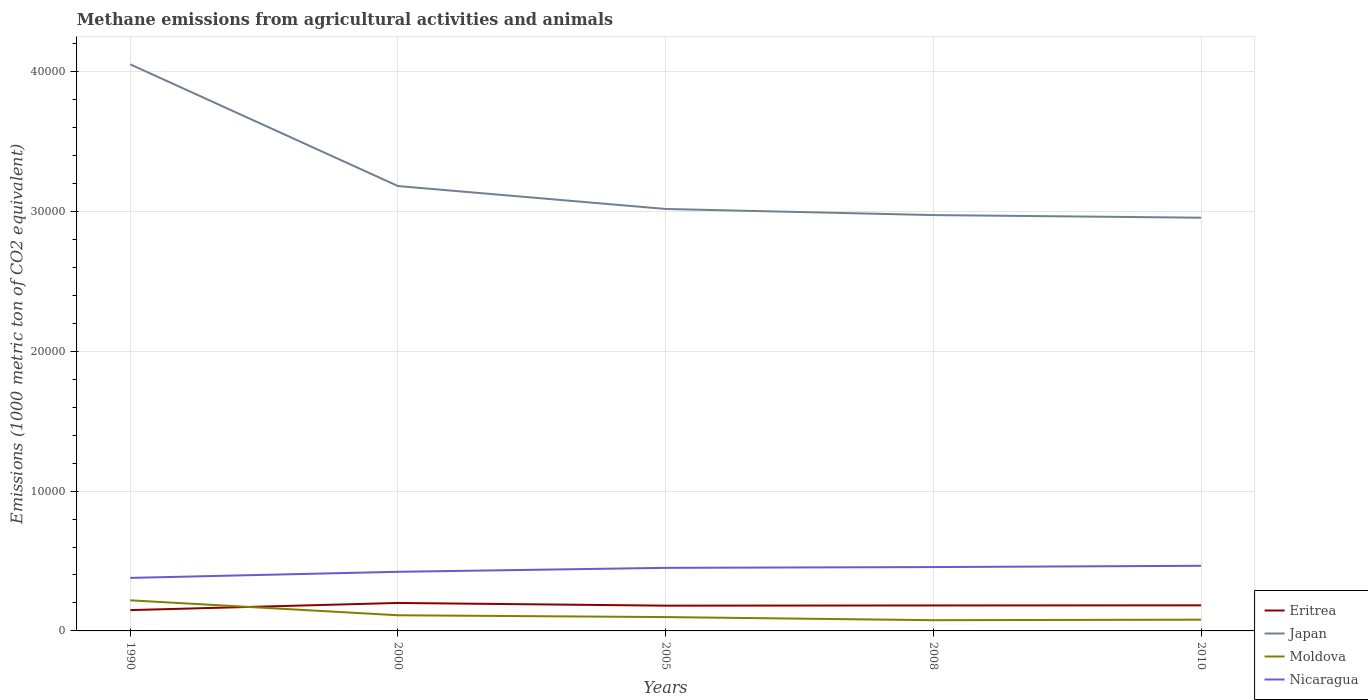How many different coloured lines are there?
Your answer should be compact. 4. Across all years, what is the maximum amount of methane emitted in Moldova?
Provide a short and direct response. 767.1. In which year was the amount of methane emitted in Moldova maximum?
Make the answer very short. 2008. What is the total amount of methane emitted in Eritrea in the graph?
Ensure brevity in your answer.  -341.7. What is the difference between the highest and the second highest amount of methane emitted in Japan?
Give a very brief answer. 1.10e+04. How many lines are there?
Provide a short and direct response. 4. Are the values on the major ticks of Y-axis written in scientific E-notation?
Offer a very short reply. No. Does the graph contain grids?
Make the answer very short. Yes. How many legend labels are there?
Keep it short and to the point. 4. What is the title of the graph?
Offer a terse response. Methane emissions from agricultural activities and animals. What is the label or title of the Y-axis?
Make the answer very short. Emissions (1000 metric ton of CO2 equivalent). What is the Emissions (1000 metric ton of CO2 equivalent) in Eritrea in 1990?
Your answer should be very brief. 1488.1. What is the Emissions (1000 metric ton of CO2 equivalent) in Japan in 1990?
Keep it short and to the point. 4.05e+04. What is the Emissions (1000 metric ton of CO2 equivalent) in Moldova in 1990?
Your answer should be very brief. 2188.8. What is the Emissions (1000 metric ton of CO2 equivalent) in Nicaragua in 1990?
Keep it short and to the point. 3791.8. What is the Emissions (1000 metric ton of CO2 equivalent) in Eritrea in 2000?
Offer a very short reply. 2000.3. What is the Emissions (1000 metric ton of CO2 equivalent) of Japan in 2000?
Provide a succinct answer. 3.18e+04. What is the Emissions (1000 metric ton of CO2 equivalent) of Moldova in 2000?
Provide a succinct answer. 1119.3. What is the Emissions (1000 metric ton of CO2 equivalent) in Nicaragua in 2000?
Your answer should be compact. 4227.1. What is the Emissions (1000 metric ton of CO2 equivalent) in Eritrea in 2005?
Your answer should be compact. 1806.6. What is the Emissions (1000 metric ton of CO2 equivalent) in Japan in 2005?
Provide a succinct answer. 3.02e+04. What is the Emissions (1000 metric ton of CO2 equivalent) in Moldova in 2005?
Your answer should be compact. 990.3. What is the Emissions (1000 metric ton of CO2 equivalent) in Nicaragua in 2005?
Offer a very short reply. 4510. What is the Emissions (1000 metric ton of CO2 equivalent) of Eritrea in 2008?
Make the answer very short. 1820.8. What is the Emissions (1000 metric ton of CO2 equivalent) in Japan in 2008?
Provide a succinct answer. 2.97e+04. What is the Emissions (1000 metric ton of CO2 equivalent) in Moldova in 2008?
Your response must be concise. 767.1. What is the Emissions (1000 metric ton of CO2 equivalent) in Nicaragua in 2008?
Your answer should be compact. 4565.5. What is the Emissions (1000 metric ton of CO2 equivalent) in Eritrea in 2010?
Keep it short and to the point. 1829.8. What is the Emissions (1000 metric ton of CO2 equivalent) in Japan in 2010?
Provide a succinct answer. 2.95e+04. What is the Emissions (1000 metric ton of CO2 equivalent) of Moldova in 2010?
Provide a short and direct response. 804.4. What is the Emissions (1000 metric ton of CO2 equivalent) of Nicaragua in 2010?
Your answer should be very brief. 4656. Across all years, what is the maximum Emissions (1000 metric ton of CO2 equivalent) of Eritrea?
Your answer should be very brief. 2000.3. Across all years, what is the maximum Emissions (1000 metric ton of CO2 equivalent) in Japan?
Offer a terse response. 4.05e+04. Across all years, what is the maximum Emissions (1000 metric ton of CO2 equivalent) in Moldova?
Ensure brevity in your answer.  2188.8. Across all years, what is the maximum Emissions (1000 metric ton of CO2 equivalent) of Nicaragua?
Provide a short and direct response. 4656. Across all years, what is the minimum Emissions (1000 metric ton of CO2 equivalent) of Eritrea?
Provide a short and direct response. 1488.1. Across all years, what is the minimum Emissions (1000 metric ton of CO2 equivalent) in Japan?
Keep it short and to the point. 2.95e+04. Across all years, what is the minimum Emissions (1000 metric ton of CO2 equivalent) of Moldova?
Keep it short and to the point. 767.1. Across all years, what is the minimum Emissions (1000 metric ton of CO2 equivalent) in Nicaragua?
Offer a very short reply. 3791.8. What is the total Emissions (1000 metric ton of CO2 equivalent) in Eritrea in the graph?
Keep it short and to the point. 8945.6. What is the total Emissions (1000 metric ton of CO2 equivalent) in Japan in the graph?
Keep it short and to the point. 1.62e+05. What is the total Emissions (1000 metric ton of CO2 equivalent) in Moldova in the graph?
Offer a terse response. 5869.9. What is the total Emissions (1000 metric ton of CO2 equivalent) of Nicaragua in the graph?
Your answer should be compact. 2.18e+04. What is the difference between the Emissions (1000 metric ton of CO2 equivalent) of Eritrea in 1990 and that in 2000?
Ensure brevity in your answer.  -512.2. What is the difference between the Emissions (1000 metric ton of CO2 equivalent) in Japan in 1990 and that in 2000?
Give a very brief answer. 8700.7. What is the difference between the Emissions (1000 metric ton of CO2 equivalent) of Moldova in 1990 and that in 2000?
Provide a succinct answer. 1069.5. What is the difference between the Emissions (1000 metric ton of CO2 equivalent) of Nicaragua in 1990 and that in 2000?
Provide a succinct answer. -435.3. What is the difference between the Emissions (1000 metric ton of CO2 equivalent) of Eritrea in 1990 and that in 2005?
Your response must be concise. -318.5. What is the difference between the Emissions (1000 metric ton of CO2 equivalent) of Japan in 1990 and that in 2005?
Ensure brevity in your answer.  1.03e+04. What is the difference between the Emissions (1000 metric ton of CO2 equivalent) in Moldova in 1990 and that in 2005?
Give a very brief answer. 1198.5. What is the difference between the Emissions (1000 metric ton of CO2 equivalent) in Nicaragua in 1990 and that in 2005?
Your answer should be very brief. -718.2. What is the difference between the Emissions (1000 metric ton of CO2 equivalent) of Eritrea in 1990 and that in 2008?
Your answer should be compact. -332.7. What is the difference between the Emissions (1000 metric ton of CO2 equivalent) of Japan in 1990 and that in 2008?
Ensure brevity in your answer.  1.08e+04. What is the difference between the Emissions (1000 metric ton of CO2 equivalent) of Moldova in 1990 and that in 2008?
Give a very brief answer. 1421.7. What is the difference between the Emissions (1000 metric ton of CO2 equivalent) in Nicaragua in 1990 and that in 2008?
Give a very brief answer. -773.7. What is the difference between the Emissions (1000 metric ton of CO2 equivalent) in Eritrea in 1990 and that in 2010?
Make the answer very short. -341.7. What is the difference between the Emissions (1000 metric ton of CO2 equivalent) of Japan in 1990 and that in 2010?
Your response must be concise. 1.10e+04. What is the difference between the Emissions (1000 metric ton of CO2 equivalent) of Moldova in 1990 and that in 2010?
Offer a very short reply. 1384.4. What is the difference between the Emissions (1000 metric ton of CO2 equivalent) in Nicaragua in 1990 and that in 2010?
Your response must be concise. -864.2. What is the difference between the Emissions (1000 metric ton of CO2 equivalent) of Eritrea in 2000 and that in 2005?
Ensure brevity in your answer.  193.7. What is the difference between the Emissions (1000 metric ton of CO2 equivalent) in Japan in 2000 and that in 2005?
Offer a very short reply. 1638. What is the difference between the Emissions (1000 metric ton of CO2 equivalent) in Moldova in 2000 and that in 2005?
Offer a terse response. 129. What is the difference between the Emissions (1000 metric ton of CO2 equivalent) of Nicaragua in 2000 and that in 2005?
Provide a short and direct response. -282.9. What is the difference between the Emissions (1000 metric ton of CO2 equivalent) of Eritrea in 2000 and that in 2008?
Give a very brief answer. 179.5. What is the difference between the Emissions (1000 metric ton of CO2 equivalent) of Japan in 2000 and that in 2008?
Offer a terse response. 2075.3. What is the difference between the Emissions (1000 metric ton of CO2 equivalent) of Moldova in 2000 and that in 2008?
Offer a very short reply. 352.2. What is the difference between the Emissions (1000 metric ton of CO2 equivalent) of Nicaragua in 2000 and that in 2008?
Ensure brevity in your answer.  -338.4. What is the difference between the Emissions (1000 metric ton of CO2 equivalent) in Eritrea in 2000 and that in 2010?
Your answer should be compact. 170.5. What is the difference between the Emissions (1000 metric ton of CO2 equivalent) in Japan in 2000 and that in 2010?
Your answer should be compact. 2263.3. What is the difference between the Emissions (1000 metric ton of CO2 equivalent) of Moldova in 2000 and that in 2010?
Ensure brevity in your answer.  314.9. What is the difference between the Emissions (1000 metric ton of CO2 equivalent) of Nicaragua in 2000 and that in 2010?
Your response must be concise. -428.9. What is the difference between the Emissions (1000 metric ton of CO2 equivalent) in Eritrea in 2005 and that in 2008?
Your response must be concise. -14.2. What is the difference between the Emissions (1000 metric ton of CO2 equivalent) in Japan in 2005 and that in 2008?
Your answer should be compact. 437.3. What is the difference between the Emissions (1000 metric ton of CO2 equivalent) of Moldova in 2005 and that in 2008?
Keep it short and to the point. 223.2. What is the difference between the Emissions (1000 metric ton of CO2 equivalent) in Nicaragua in 2005 and that in 2008?
Offer a very short reply. -55.5. What is the difference between the Emissions (1000 metric ton of CO2 equivalent) in Eritrea in 2005 and that in 2010?
Make the answer very short. -23.2. What is the difference between the Emissions (1000 metric ton of CO2 equivalent) of Japan in 2005 and that in 2010?
Ensure brevity in your answer.  625.3. What is the difference between the Emissions (1000 metric ton of CO2 equivalent) in Moldova in 2005 and that in 2010?
Offer a very short reply. 185.9. What is the difference between the Emissions (1000 metric ton of CO2 equivalent) in Nicaragua in 2005 and that in 2010?
Provide a short and direct response. -146. What is the difference between the Emissions (1000 metric ton of CO2 equivalent) in Japan in 2008 and that in 2010?
Keep it short and to the point. 188. What is the difference between the Emissions (1000 metric ton of CO2 equivalent) in Moldova in 2008 and that in 2010?
Provide a succinct answer. -37.3. What is the difference between the Emissions (1000 metric ton of CO2 equivalent) of Nicaragua in 2008 and that in 2010?
Make the answer very short. -90.5. What is the difference between the Emissions (1000 metric ton of CO2 equivalent) in Eritrea in 1990 and the Emissions (1000 metric ton of CO2 equivalent) in Japan in 2000?
Give a very brief answer. -3.03e+04. What is the difference between the Emissions (1000 metric ton of CO2 equivalent) of Eritrea in 1990 and the Emissions (1000 metric ton of CO2 equivalent) of Moldova in 2000?
Provide a short and direct response. 368.8. What is the difference between the Emissions (1000 metric ton of CO2 equivalent) in Eritrea in 1990 and the Emissions (1000 metric ton of CO2 equivalent) in Nicaragua in 2000?
Your response must be concise. -2739. What is the difference between the Emissions (1000 metric ton of CO2 equivalent) in Japan in 1990 and the Emissions (1000 metric ton of CO2 equivalent) in Moldova in 2000?
Ensure brevity in your answer.  3.94e+04. What is the difference between the Emissions (1000 metric ton of CO2 equivalent) in Japan in 1990 and the Emissions (1000 metric ton of CO2 equivalent) in Nicaragua in 2000?
Give a very brief answer. 3.63e+04. What is the difference between the Emissions (1000 metric ton of CO2 equivalent) of Moldova in 1990 and the Emissions (1000 metric ton of CO2 equivalent) of Nicaragua in 2000?
Your response must be concise. -2038.3. What is the difference between the Emissions (1000 metric ton of CO2 equivalent) in Eritrea in 1990 and the Emissions (1000 metric ton of CO2 equivalent) in Japan in 2005?
Give a very brief answer. -2.87e+04. What is the difference between the Emissions (1000 metric ton of CO2 equivalent) of Eritrea in 1990 and the Emissions (1000 metric ton of CO2 equivalent) of Moldova in 2005?
Your response must be concise. 497.8. What is the difference between the Emissions (1000 metric ton of CO2 equivalent) in Eritrea in 1990 and the Emissions (1000 metric ton of CO2 equivalent) in Nicaragua in 2005?
Offer a very short reply. -3021.9. What is the difference between the Emissions (1000 metric ton of CO2 equivalent) of Japan in 1990 and the Emissions (1000 metric ton of CO2 equivalent) of Moldova in 2005?
Offer a terse response. 3.95e+04. What is the difference between the Emissions (1000 metric ton of CO2 equivalent) of Japan in 1990 and the Emissions (1000 metric ton of CO2 equivalent) of Nicaragua in 2005?
Offer a terse response. 3.60e+04. What is the difference between the Emissions (1000 metric ton of CO2 equivalent) of Moldova in 1990 and the Emissions (1000 metric ton of CO2 equivalent) of Nicaragua in 2005?
Make the answer very short. -2321.2. What is the difference between the Emissions (1000 metric ton of CO2 equivalent) in Eritrea in 1990 and the Emissions (1000 metric ton of CO2 equivalent) in Japan in 2008?
Keep it short and to the point. -2.82e+04. What is the difference between the Emissions (1000 metric ton of CO2 equivalent) in Eritrea in 1990 and the Emissions (1000 metric ton of CO2 equivalent) in Moldova in 2008?
Your answer should be compact. 721. What is the difference between the Emissions (1000 metric ton of CO2 equivalent) of Eritrea in 1990 and the Emissions (1000 metric ton of CO2 equivalent) of Nicaragua in 2008?
Ensure brevity in your answer.  -3077.4. What is the difference between the Emissions (1000 metric ton of CO2 equivalent) of Japan in 1990 and the Emissions (1000 metric ton of CO2 equivalent) of Moldova in 2008?
Ensure brevity in your answer.  3.97e+04. What is the difference between the Emissions (1000 metric ton of CO2 equivalent) in Japan in 1990 and the Emissions (1000 metric ton of CO2 equivalent) in Nicaragua in 2008?
Offer a very short reply. 3.59e+04. What is the difference between the Emissions (1000 metric ton of CO2 equivalent) of Moldova in 1990 and the Emissions (1000 metric ton of CO2 equivalent) of Nicaragua in 2008?
Give a very brief answer. -2376.7. What is the difference between the Emissions (1000 metric ton of CO2 equivalent) in Eritrea in 1990 and the Emissions (1000 metric ton of CO2 equivalent) in Japan in 2010?
Your response must be concise. -2.81e+04. What is the difference between the Emissions (1000 metric ton of CO2 equivalent) in Eritrea in 1990 and the Emissions (1000 metric ton of CO2 equivalent) in Moldova in 2010?
Offer a very short reply. 683.7. What is the difference between the Emissions (1000 metric ton of CO2 equivalent) in Eritrea in 1990 and the Emissions (1000 metric ton of CO2 equivalent) in Nicaragua in 2010?
Your answer should be very brief. -3167.9. What is the difference between the Emissions (1000 metric ton of CO2 equivalent) in Japan in 1990 and the Emissions (1000 metric ton of CO2 equivalent) in Moldova in 2010?
Make the answer very short. 3.97e+04. What is the difference between the Emissions (1000 metric ton of CO2 equivalent) of Japan in 1990 and the Emissions (1000 metric ton of CO2 equivalent) of Nicaragua in 2010?
Offer a terse response. 3.59e+04. What is the difference between the Emissions (1000 metric ton of CO2 equivalent) in Moldova in 1990 and the Emissions (1000 metric ton of CO2 equivalent) in Nicaragua in 2010?
Ensure brevity in your answer.  -2467.2. What is the difference between the Emissions (1000 metric ton of CO2 equivalent) of Eritrea in 2000 and the Emissions (1000 metric ton of CO2 equivalent) of Japan in 2005?
Provide a succinct answer. -2.82e+04. What is the difference between the Emissions (1000 metric ton of CO2 equivalent) of Eritrea in 2000 and the Emissions (1000 metric ton of CO2 equivalent) of Moldova in 2005?
Ensure brevity in your answer.  1010. What is the difference between the Emissions (1000 metric ton of CO2 equivalent) in Eritrea in 2000 and the Emissions (1000 metric ton of CO2 equivalent) in Nicaragua in 2005?
Provide a succinct answer. -2509.7. What is the difference between the Emissions (1000 metric ton of CO2 equivalent) of Japan in 2000 and the Emissions (1000 metric ton of CO2 equivalent) of Moldova in 2005?
Provide a short and direct response. 3.08e+04. What is the difference between the Emissions (1000 metric ton of CO2 equivalent) in Japan in 2000 and the Emissions (1000 metric ton of CO2 equivalent) in Nicaragua in 2005?
Keep it short and to the point. 2.73e+04. What is the difference between the Emissions (1000 metric ton of CO2 equivalent) of Moldova in 2000 and the Emissions (1000 metric ton of CO2 equivalent) of Nicaragua in 2005?
Make the answer very short. -3390.7. What is the difference between the Emissions (1000 metric ton of CO2 equivalent) in Eritrea in 2000 and the Emissions (1000 metric ton of CO2 equivalent) in Japan in 2008?
Your answer should be compact. -2.77e+04. What is the difference between the Emissions (1000 metric ton of CO2 equivalent) in Eritrea in 2000 and the Emissions (1000 metric ton of CO2 equivalent) in Moldova in 2008?
Offer a very short reply. 1233.2. What is the difference between the Emissions (1000 metric ton of CO2 equivalent) of Eritrea in 2000 and the Emissions (1000 metric ton of CO2 equivalent) of Nicaragua in 2008?
Provide a short and direct response. -2565.2. What is the difference between the Emissions (1000 metric ton of CO2 equivalent) in Japan in 2000 and the Emissions (1000 metric ton of CO2 equivalent) in Moldova in 2008?
Ensure brevity in your answer.  3.10e+04. What is the difference between the Emissions (1000 metric ton of CO2 equivalent) in Japan in 2000 and the Emissions (1000 metric ton of CO2 equivalent) in Nicaragua in 2008?
Offer a very short reply. 2.72e+04. What is the difference between the Emissions (1000 metric ton of CO2 equivalent) in Moldova in 2000 and the Emissions (1000 metric ton of CO2 equivalent) in Nicaragua in 2008?
Offer a very short reply. -3446.2. What is the difference between the Emissions (1000 metric ton of CO2 equivalent) of Eritrea in 2000 and the Emissions (1000 metric ton of CO2 equivalent) of Japan in 2010?
Make the answer very short. -2.75e+04. What is the difference between the Emissions (1000 metric ton of CO2 equivalent) in Eritrea in 2000 and the Emissions (1000 metric ton of CO2 equivalent) in Moldova in 2010?
Offer a terse response. 1195.9. What is the difference between the Emissions (1000 metric ton of CO2 equivalent) in Eritrea in 2000 and the Emissions (1000 metric ton of CO2 equivalent) in Nicaragua in 2010?
Your response must be concise. -2655.7. What is the difference between the Emissions (1000 metric ton of CO2 equivalent) of Japan in 2000 and the Emissions (1000 metric ton of CO2 equivalent) of Moldova in 2010?
Your response must be concise. 3.10e+04. What is the difference between the Emissions (1000 metric ton of CO2 equivalent) in Japan in 2000 and the Emissions (1000 metric ton of CO2 equivalent) in Nicaragua in 2010?
Your answer should be compact. 2.72e+04. What is the difference between the Emissions (1000 metric ton of CO2 equivalent) of Moldova in 2000 and the Emissions (1000 metric ton of CO2 equivalent) of Nicaragua in 2010?
Your answer should be very brief. -3536.7. What is the difference between the Emissions (1000 metric ton of CO2 equivalent) in Eritrea in 2005 and the Emissions (1000 metric ton of CO2 equivalent) in Japan in 2008?
Your response must be concise. -2.79e+04. What is the difference between the Emissions (1000 metric ton of CO2 equivalent) in Eritrea in 2005 and the Emissions (1000 metric ton of CO2 equivalent) in Moldova in 2008?
Provide a short and direct response. 1039.5. What is the difference between the Emissions (1000 metric ton of CO2 equivalent) of Eritrea in 2005 and the Emissions (1000 metric ton of CO2 equivalent) of Nicaragua in 2008?
Give a very brief answer. -2758.9. What is the difference between the Emissions (1000 metric ton of CO2 equivalent) of Japan in 2005 and the Emissions (1000 metric ton of CO2 equivalent) of Moldova in 2008?
Ensure brevity in your answer.  2.94e+04. What is the difference between the Emissions (1000 metric ton of CO2 equivalent) of Japan in 2005 and the Emissions (1000 metric ton of CO2 equivalent) of Nicaragua in 2008?
Make the answer very short. 2.56e+04. What is the difference between the Emissions (1000 metric ton of CO2 equivalent) in Moldova in 2005 and the Emissions (1000 metric ton of CO2 equivalent) in Nicaragua in 2008?
Provide a succinct answer. -3575.2. What is the difference between the Emissions (1000 metric ton of CO2 equivalent) in Eritrea in 2005 and the Emissions (1000 metric ton of CO2 equivalent) in Japan in 2010?
Keep it short and to the point. -2.77e+04. What is the difference between the Emissions (1000 metric ton of CO2 equivalent) in Eritrea in 2005 and the Emissions (1000 metric ton of CO2 equivalent) in Moldova in 2010?
Make the answer very short. 1002.2. What is the difference between the Emissions (1000 metric ton of CO2 equivalent) in Eritrea in 2005 and the Emissions (1000 metric ton of CO2 equivalent) in Nicaragua in 2010?
Your response must be concise. -2849.4. What is the difference between the Emissions (1000 metric ton of CO2 equivalent) of Japan in 2005 and the Emissions (1000 metric ton of CO2 equivalent) of Moldova in 2010?
Give a very brief answer. 2.94e+04. What is the difference between the Emissions (1000 metric ton of CO2 equivalent) of Japan in 2005 and the Emissions (1000 metric ton of CO2 equivalent) of Nicaragua in 2010?
Ensure brevity in your answer.  2.55e+04. What is the difference between the Emissions (1000 metric ton of CO2 equivalent) in Moldova in 2005 and the Emissions (1000 metric ton of CO2 equivalent) in Nicaragua in 2010?
Provide a succinct answer. -3665.7. What is the difference between the Emissions (1000 metric ton of CO2 equivalent) in Eritrea in 2008 and the Emissions (1000 metric ton of CO2 equivalent) in Japan in 2010?
Provide a short and direct response. -2.77e+04. What is the difference between the Emissions (1000 metric ton of CO2 equivalent) in Eritrea in 2008 and the Emissions (1000 metric ton of CO2 equivalent) in Moldova in 2010?
Make the answer very short. 1016.4. What is the difference between the Emissions (1000 metric ton of CO2 equivalent) of Eritrea in 2008 and the Emissions (1000 metric ton of CO2 equivalent) of Nicaragua in 2010?
Offer a very short reply. -2835.2. What is the difference between the Emissions (1000 metric ton of CO2 equivalent) of Japan in 2008 and the Emissions (1000 metric ton of CO2 equivalent) of Moldova in 2010?
Your answer should be very brief. 2.89e+04. What is the difference between the Emissions (1000 metric ton of CO2 equivalent) in Japan in 2008 and the Emissions (1000 metric ton of CO2 equivalent) in Nicaragua in 2010?
Your answer should be very brief. 2.51e+04. What is the difference between the Emissions (1000 metric ton of CO2 equivalent) in Moldova in 2008 and the Emissions (1000 metric ton of CO2 equivalent) in Nicaragua in 2010?
Keep it short and to the point. -3888.9. What is the average Emissions (1000 metric ton of CO2 equivalent) in Eritrea per year?
Provide a succinct answer. 1789.12. What is the average Emissions (1000 metric ton of CO2 equivalent) of Japan per year?
Ensure brevity in your answer.  3.24e+04. What is the average Emissions (1000 metric ton of CO2 equivalent) of Moldova per year?
Your response must be concise. 1173.98. What is the average Emissions (1000 metric ton of CO2 equivalent) in Nicaragua per year?
Make the answer very short. 4350.08. In the year 1990, what is the difference between the Emissions (1000 metric ton of CO2 equivalent) in Eritrea and Emissions (1000 metric ton of CO2 equivalent) in Japan?
Your response must be concise. -3.90e+04. In the year 1990, what is the difference between the Emissions (1000 metric ton of CO2 equivalent) in Eritrea and Emissions (1000 metric ton of CO2 equivalent) in Moldova?
Your response must be concise. -700.7. In the year 1990, what is the difference between the Emissions (1000 metric ton of CO2 equivalent) in Eritrea and Emissions (1000 metric ton of CO2 equivalent) in Nicaragua?
Provide a succinct answer. -2303.7. In the year 1990, what is the difference between the Emissions (1000 metric ton of CO2 equivalent) in Japan and Emissions (1000 metric ton of CO2 equivalent) in Moldova?
Give a very brief answer. 3.83e+04. In the year 1990, what is the difference between the Emissions (1000 metric ton of CO2 equivalent) of Japan and Emissions (1000 metric ton of CO2 equivalent) of Nicaragua?
Provide a short and direct response. 3.67e+04. In the year 1990, what is the difference between the Emissions (1000 metric ton of CO2 equivalent) of Moldova and Emissions (1000 metric ton of CO2 equivalent) of Nicaragua?
Ensure brevity in your answer.  -1603. In the year 2000, what is the difference between the Emissions (1000 metric ton of CO2 equivalent) in Eritrea and Emissions (1000 metric ton of CO2 equivalent) in Japan?
Your response must be concise. -2.98e+04. In the year 2000, what is the difference between the Emissions (1000 metric ton of CO2 equivalent) in Eritrea and Emissions (1000 metric ton of CO2 equivalent) in Moldova?
Give a very brief answer. 881. In the year 2000, what is the difference between the Emissions (1000 metric ton of CO2 equivalent) of Eritrea and Emissions (1000 metric ton of CO2 equivalent) of Nicaragua?
Make the answer very short. -2226.8. In the year 2000, what is the difference between the Emissions (1000 metric ton of CO2 equivalent) of Japan and Emissions (1000 metric ton of CO2 equivalent) of Moldova?
Your answer should be very brief. 3.07e+04. In the year 2000, what is the difference between the Emissions (1000 metric ton of CO2 equivalent) in Japan and Emissions (1000 metric ton of CO2 equivalent) in Nicaragua?
Offer a terse response. 2.76e+04. In the year 2000, what is the difference between the Emissions (1000 metric ton of CO2 equivalent) of Moldova and Emissions (1000 metric ton of CO2 equivalent) of Nicaragua?
Make the answer very short. -3107.8. In the year 2005, what is the difference between the Emissions (1000 metric ton of CO2 equivalent) of Eritrea and Emissions (1000 metric ton of CO2 equivalent) of Japan?
Provide a short and direct response. -2.84e+04. In the year 2005, what is the difference between the Emissions (1000 metric ton of CO2 equivalent) of Eritrea and Emissions (1000 metric ton of CO2 equivalent) of Moldova?
Your answer should be compact. 816.3. In the year 2005, what is the difference between the Emissions (1000 metric ton of CO2 equivalent) in Eritrea and Emissions (1000 metric ton of CO2 equivalent) in Nicaragua?
Offer a terse response. -2703.4. In the year 2005, what is the difference between the Emissions (1000 metric ton of CO2 equivalent) in Japan and Emissions (1000 metric ton of CO2 equivalent) in Moldova?
Your response must be concise. 2.92e+04. In the year 2005, what is the difference between the Emissions (1000 metric ton of CO2 equivalent) of Japan and Emissions (1000 metric ton of CO2 equivalent) of Nicaragua?
Offer a terse response. 2.57e+04. In the year 2005, what is the difference between the Emissions (1000 metric ton of CO2 equivalent) in Moldova and Emissions (1000 metric ton of CO2 equivalent) in Nicaragua?
Ensure brevity in your answer.  -3519.7. In the year 2008, what is the difference between the Emissions (1000 metric ton of CO2 equivalent) of Eritrea and Emissions (1000 metric ton of CO2 equivalent) of Japan?
Offer a terse response. -2.79e+04. In the year 2008, what is the difference between the Emissions (1000 metric ton of CO2 equivalent) in Eritrea and Emissions (1000 metric ton of CO2 equivalent) in Moldova?
Keep it short and to the point. 1053.7. In the year 2008, what is the difference between the Emissions (1000 metric ton of CO2 equivalent) of Eritrea and Emissions (1000 metric ton of CO2 equivalent) of Nicaragua?
Make the answer very short. -2744.7. In the year 2008, what is the difference between the Emissions (1000 metric ton of CO2 equivalent) in Japan and Emissions (1000 metric ton of CO2 equivalent) in Moldova?
Your answer should be very brief. 2.90e+04. In the year 2008, what is the difference between the Emissions (1000 metric ton of CO2 equivalent) in Japan and Emissions (1000 metric ton of CO2 equivalent) in Nicaragua?
Your answer should be compact. 2.52e+04. In the year 2008, what is the difference between the Emissions (1000 metric ton of CO2 equivalent) of Moldova and Emissions (1000 metric ton of CO2 equivalent) of Nicaragua?
Your response must be concise. -3798.4. In the year 2010, what is the difference between the Emissions (1000 metric ton of CO2 equivalent) in Eritrea and Emissions (1000 metric ton of CO2 equivalent) in Japan?
Provide a short and direct response. -2.77e+04. In the year 2010, what is the difference between the Emissions (1000 metric ton of CO2 equivalent) in Eritrea and Emissions (1000 metric ton of CO2 equivalent) in Moldova?
Your response must be concise. 1025.4. In the year 2010, what is the difference between the Emissions (1000 metric ton of CO2 equivalent) of Eritrea and Emissions (1000 metric ton of CO2 equivalent) of Nicaragua?
Your response must be concise. -2826.2. In the year 2010, what is the difference between the Emissions (1000 metric ton of CO2 equivalent) of Japan and Emissions (1000 metric ton of CO2 equivalent) of Moldova?
Offer a very short reply. 2.87e+04. In the year 2010, what is the difference between the Emissions (1000 metric ton of CO2 equivalent) of Japan and Emissions (1000 metric ton of CO2 equivalent) of Nicaragua?
Keep it short and to the point. 2.49e+04. In the year 2010, what is the difference between the Emissions (1000 metric ton of CO2 equivalent) in Moldova and Emissions (1000 metric ton of CO2 equivalent) in Nicaragua?
Provide a short and direct response. -3851.6. What is the ratio of the Emissions (1000 metric ton of CO2 equivalent) in Eritrea in 1990 to that in 2000?
Ensure brevity in your answer.  0.74. What is the ratio of the Emissions (1000 metric ton of CO2 equivalent) of Japan in 1990 to that in 2000?
Your answer should be very brief. 1.27. What is the ratio of the Emissions (1000 metric ton of CO2 equivalent) in Moldova in 1990 to that in 2000?
Offer a terse response. 1.96. What is the ratio of the Emissions (1000 metric ton of CO2 equivalent) of Nicaragua in 1990 to that in 2000?
Your answer should be compact. 0.9. What is the ratio of the Emissions (1000 metric ton of CO2 equivalent) of Eritrea in 1990 to that in 2005?
Ensure brevity in your answer.  0.82. What is the ratio of the Emissions (1000 metric ton of CO2 equivalent) of Japan in 1990 to that in 2005?
Offer a very short reply. 1.34. What is the ratio of the Emissions (1000 metric ton of CO2 equivalent) in Moldova in 1990 to that in 2005?
Ensure brevity in your answer.  2.21. What is the ratio of the Emissions (1000 metric ton of CO2 equivalent) in Nicaragua in 1990 to that in 2005?
Provide a succinct answer. 0.84. What is the ratio of the Emissions (1000 metric ton of CO2 equivalent) in Eritrea in 1990 to that in 2008?
Give a very brief answer. 0.82. What is the ratio of the Emissions (1000 metric ton of CO2 equivalent) in Japan in 1990 to that in 2008?
Make the answer very short. 1.36. What is the ratio of the Emissions (1000 metric ton of CO2 equivalent) of Moldova in 1990 to that in 2008?
Provide a succinct answer. 2.85. What is the ratio of the Emissions (1000 metric ton of CO2 equivalent) of Nicaragua in 1990 to that in 2008?
Keep it short and to the point. 0.83. What is the ratio of the Emissions (1000 metric ton of CO2 equivalent) in Eritrea in 1990 to that in 2010?
Your response must be concise. 0.81. What is the ratio of the Emissions (1000 metric ton of CO2 equivalent) in Japan in 1990 to that in 2010?
Provide a succinct answer. 1.37. What is the ratio of the Emissions (1000 metric ton of CO2 equivalent) in Moldova in 1990 to that in 2010?
Offer a very short reply. 2.72. What is the ratio of the Emissions (1000 metric ton of CO2 equivalent) in Nicaragua in 1990 to that in 2010?
Give a very brief answer. 0.81. What is the ratio of the Emissions (1000 metric ton of CO2 equivalent) in Eritrea in 2000 to that in 2005?
Ensure brevity in your answer.  1.11. What is the ratio of the Emissions (1000 metric ton of CO2 equivalent) of Japan in 2000 to that in 2005?
Provide a succinct answer. 1.05. What is the ratio of the Emissions (1000 metric ton of CO2 equivalent) in Moldova in 2000 to that in 2005?
Offer a terse response. 1.13. What is the ratio of the Emissions (1000 metric ton of CO2 equivalent) in Nicaragua in 2000 to that in 2005?
Keep it short and to the point. 0.94. What is the ratio of the Emissions (1000 metric ton of CO2 equivalent) in Eritrea in 2000 to that in 2008?
Ensure brevity in your answer.  1.1. What is the ratio of the Emissions (1000 metric ton of CO2 equivalent) of Japan in 2000 to that in 2008?
Offer a very short reply. 1.07. What is the ratio of the Emissions (1000 metric ton of CO2 equivalent) in Moldova in 2000 to that in 2008?
Your answer should be very brief. 1.46. What is the ratio of the Emissions (1000 metric ton of CO2 equivalent) in Nicaragua in 2000 to that in 2008?
Provide a short and direct response. 0.93. What is the ratio of the Emissions (1000 metric ton of CO2 equivalent) of Eritrea in 2000 to that in 2010?
Provide a short and direct response. 1.09. What is the ratio of the Emissions (1000 metric ton of CO2 equivalent) of Japan in 2000 to that in 2010?
Provide a succinct answer. 1.08. What is the ratio of the Emissions (1000 metric ton of CO2 equivalent) in Moldova in 2000 to that in 2010?
Offer a very short reply. 1.39. What is the ratio of the Emissions (1000 metric ton of CO2 equivalent) in Nicaragua in 2000 to that in 2010?
Ensure brevity in your answer.  0.91. What is the ratio of the Emissions (1000 metric ton of CO2 equivalent) of Eritrea in 2005 to that in 2008?
Offer a very short reply. 0.99. What is the ratio of the Emissions (1000 metric ton of CO2 equivalent) in Japan in 2005 to that in 2008?
Your answer should be very brief. 1.01. What is the ratio of the Emissions (1000 metric ton of CO2 equivalent) of Moldova in 2005 to that in 2008?
Your answer should be very brief. 1.29. What is the ratio of the Emissions (1000 metric ton of CO2 equivalent) of Eritrea in 2005 to that in 2010?
Your answer should be very brief. 0.99. What is the ratio of the Emissions (1000 metric ton of CO2 equivalent) of Japan in 2005 to that in 2010?
Your answer should be compact. 1.02. What is the ratio of the Emissions (1000 metric ton of CO2 equivalent) in Moldova in 2005 to that in 2010?
Provide a short and direct response. 1.23. What is the ratio of the Emissions (1000 metric ton of CO2 equivalent) of Nicaragua in 2005 to that in 2010?
Your response must be concise. 0.97. What is the ratio of the Emissions (1000 metric ton of CO2 equivalent) in Eritrea in 2008 to that in 2010?
Make the answer very short. 1. What is the ratio of the Emissions (1000 metric ton of CO2 equivalent) of Japan in 2008 to that in 2010?
Give a very brief answer. 1.01. What is the ratio of the Emissions (1000 metric ton of CO2 equivalent) in Moldova in 2008 to that in 2010?
Your response must be concise. 0.95. What is the ratio of the Emissions (1000 metric ton of CO2 equivalent) in Nicaragua in 2008 to that in 2010?
Ensure brevity in your answer.  0.98. What is the difference between the highest and the second highest Emissions (1000 metric ton of CO2 equivalent) in Eritrea?
Offer a terse response. 170.5. What is the difference between the highest and the second highest Emissions (1000 metric ton of CO2 equivalent) in Japan?
Provide a succinct answer. 8700.7. What is the difference between the highest and the second highest Emissions (1000 metric ton of CO2 equivalent) of Moldova?
Keep it short and to the point. 1069.5. What is the difference between the highest and the second highest Emissions (1000 metric ton of CO2 equivalent) of Nicaragua?
Give a very brief answer. 90.5. What is the difference between the highest and the lowest Emissions (1000 metric ton of CO2 equivalent) in Eritrea?
Provide a succinct answer. 512.2. What is the difference between the highest and the lowest Emissions (1000 metric ton of CO2 equivalent) of Japan?
Your response must be concise. 1.10e+04. What is the difference between the highest and the lowest Emissions (1000 metric ton of CO2 equivalent) in Moldova?
Your answer should be very brief. 1421.7. What is the difference between the highest and the lowest Emissions (1000 metric ton of CO2 equivalent) of Nicaragua?
Your answer should be compact. 864.2. 